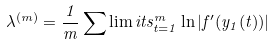Convert formula to latex. <formula><loc_0><loc_0><loc_500><loc_500>\lambda ^ { ( m ) } = \frac { 1 } { m } \sum \lim i t s _ { t = 1 } ^ { m } \ln | f ^ { \prime } ( y _ { 1 } ( t ) ) |</formula> 